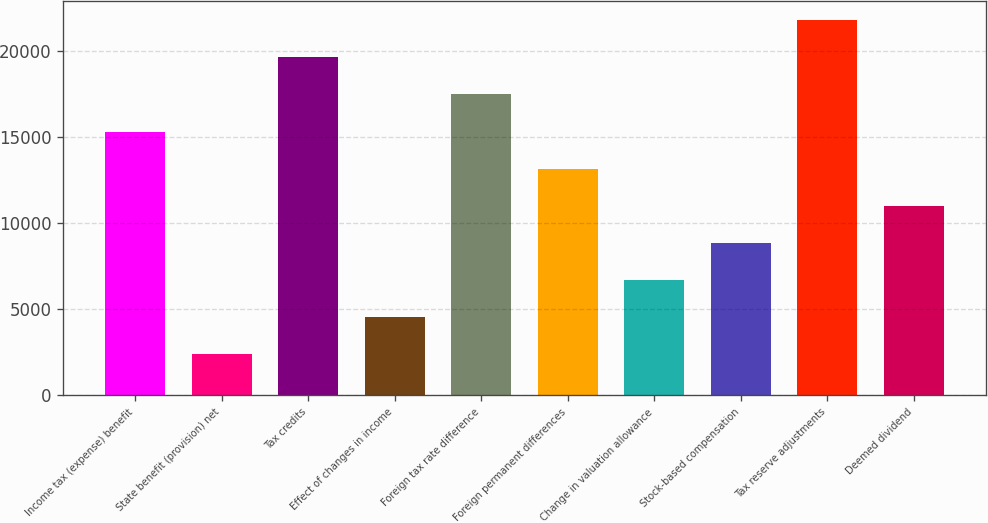Convert chart. <chart><loc_0><loc_0><loc_500><loc_500><bar_chart><fcel>Income tax (expense) benefit<fcel>State benefit (provision) net<fcel>Tax credits<fcel>Effect of changes in income<fcel>Foreign tax rate difference<fcel>Foreign permanent differences<fcel>Change in valuation allowance<fcel>Stock-based compensation<fcel>Tax reserve adjustments<fcel>Deemed dividend<nl><fcel>15316.5<fcel>2371.5<fcel>19631.5<fcel>4529<fcel>17474<fcel>13159<fcel>6686.5<fcel>8844<fcel>21789<fcel>11001.5<nl></chart> 